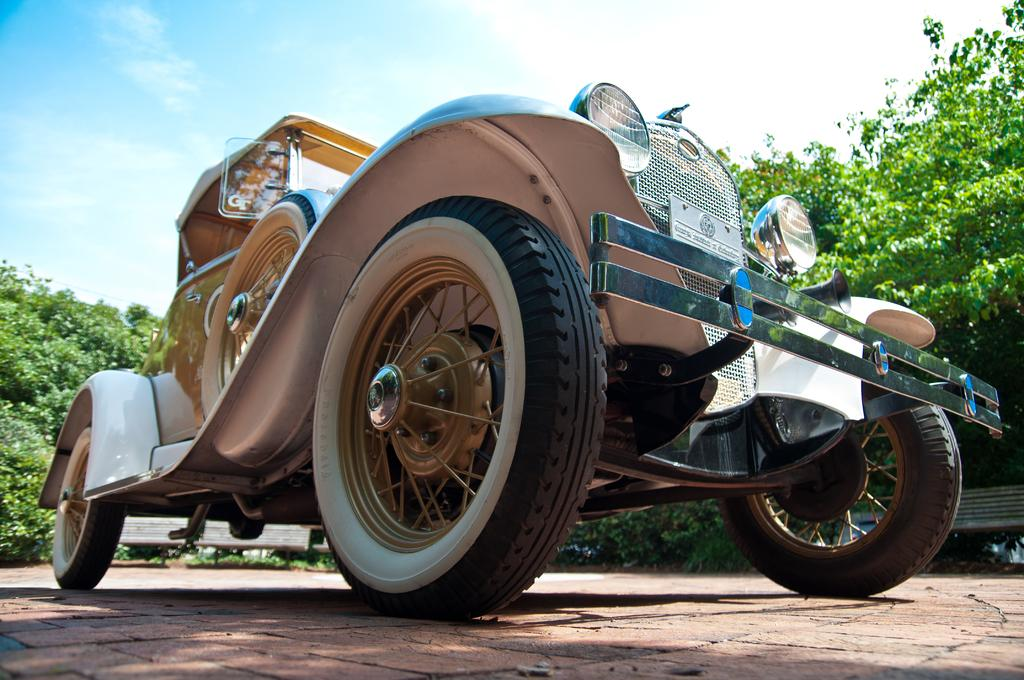What type of vehicle can be seen in the image? There is a vehicle present in the image, but the specific type is not mentioned in the facts. What is the surface on which the vehicle is located? The ground is visible in the image, and the vehicle is likely on the ground. What type of seating is available in the image? There are benches in the image. What type of vegetation is present in the image? Trees are present in the image. What is visible in the background of the image? The sky is visible in the image, and clouds are visible in the sky. What does your aunt desire in the image? There is no mention of an aunt or any desires in the image. The image only contains a vehicle, the ground, benches, trees, and the sky. 